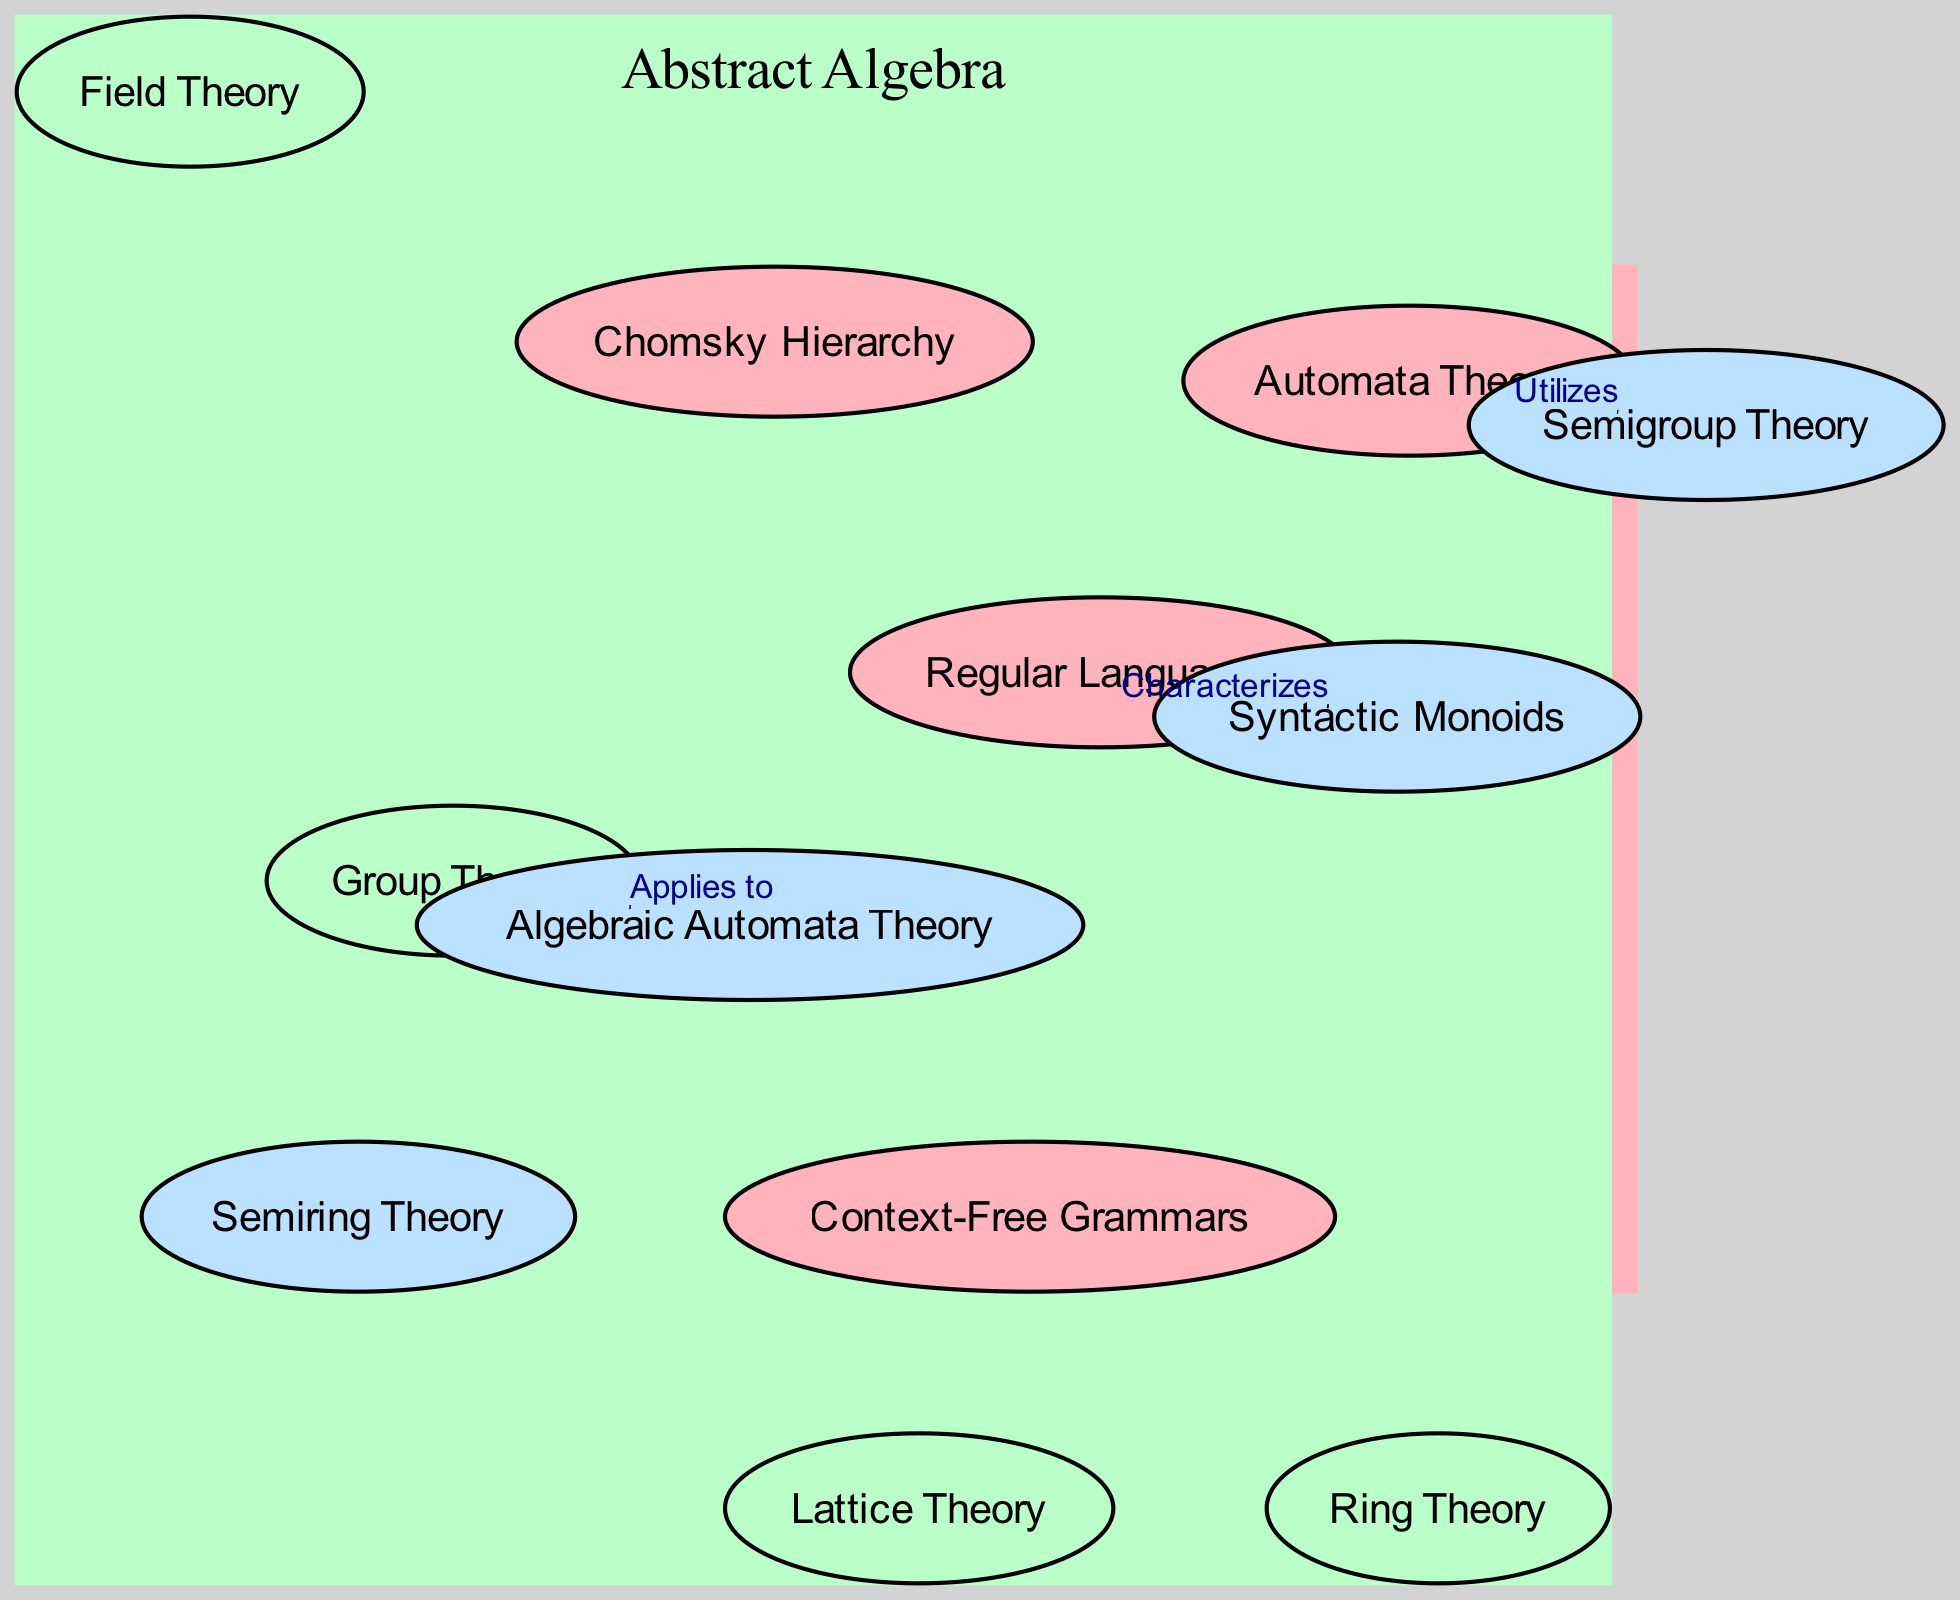What are the main topics in Formal Language Theory? The diagram lists four main elements under the Formal Language Theory set: Regular Languages, Context-Free Grammars, Chomsky Hierarchy, and Automata Theory.
Answer: Regular Languages, Context-Free Grammars, Chomsky Hierarchy, Automata Theory How many elements are in the Abstract Algebra set? The Abstract Algebra set contains four distinct elements: Group Theory, Ring Theory, Field Theory, and Lattice Theory.
Answer: 4 Which theory is characterized by Syntactic Monoids? According to the diagram, Syntactic Monoids is characterized by Regular Languages, indicating a direct relationship.
Answer: Regular Languages What relationship is established between Group Theory and Algebraic Automata Theory? The diagram states that the relationship between Group Theory and Algebraic Automata Theory is labeled as "Applies to,” establishing a direct connection in their interaction.
Answer: Applies to Which element in the intersection utilizes Automata Theory? The diagram indicates that Semigroup Theory is the element in the intersection that utilizes Automata Theory, showing how concepts from both fields interrelate.
Answer: Semigroup Theory How many relationships are depicted in the diagram? Upon examining the diagram, it can be noted that there are three defined relationships connecting elements from the Formal Language Theory and Abstract Algebra sets.
Answer: 3 What is the significance of the intersection in the diagram? The intersection showcases elements that represent the crossover between Formal Language Theory and Abstract Algebra, specifically focusing on concepts that are fundamental to both areas of study, indicating shared theories and applications.
Answer: Shared theories and applications Which two elements are directly linked by the label "Utilizes"? The diagram shows that Automata Theory is directly linked to Semigroup Theory with the label "Utilizes," implying that concepts from Automata Theory play a role in understanding Semigroup Theory.
Answer: Automata Theory, Semigroup Theory What does the connection labeled "Characterizes" indicate? The connection labeled "Characterizes" indicates that Regular Languages specifically provide a characterization for Syntactic Monoids, highlighting a foundational relationship where one concept helps define the other within the context of the diagram.
Answer: Regular Languages, Syntactic Monoids 